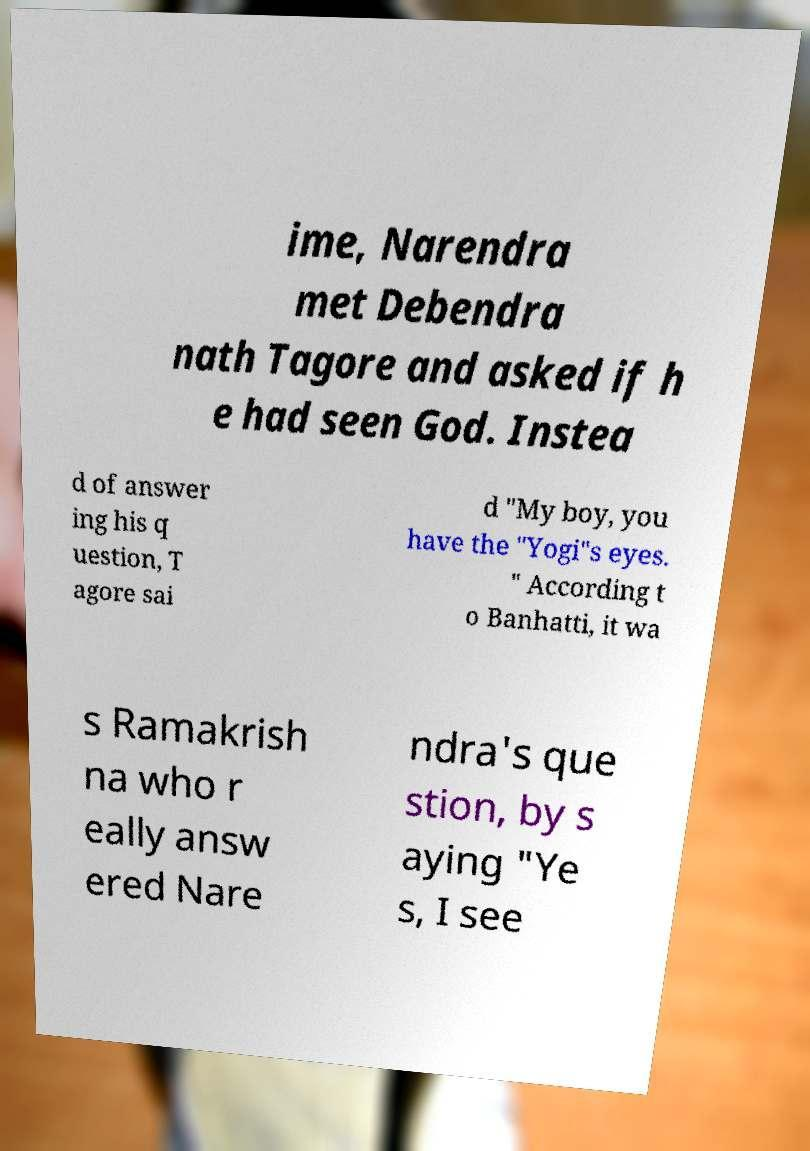Please read and relay the text visible in this image. What does it say? ime, Narendra met Debendra nath Tagore and asked if h e had seen God. Instea d of answer ing his q uestion, T agore sai d "My boy, you have the "Yogi"s eyes. " According t o Banhatti, it wa s Ramakrish na who r eally answ ered Nare ndra's que stion, by s aying "Ye s, I see 